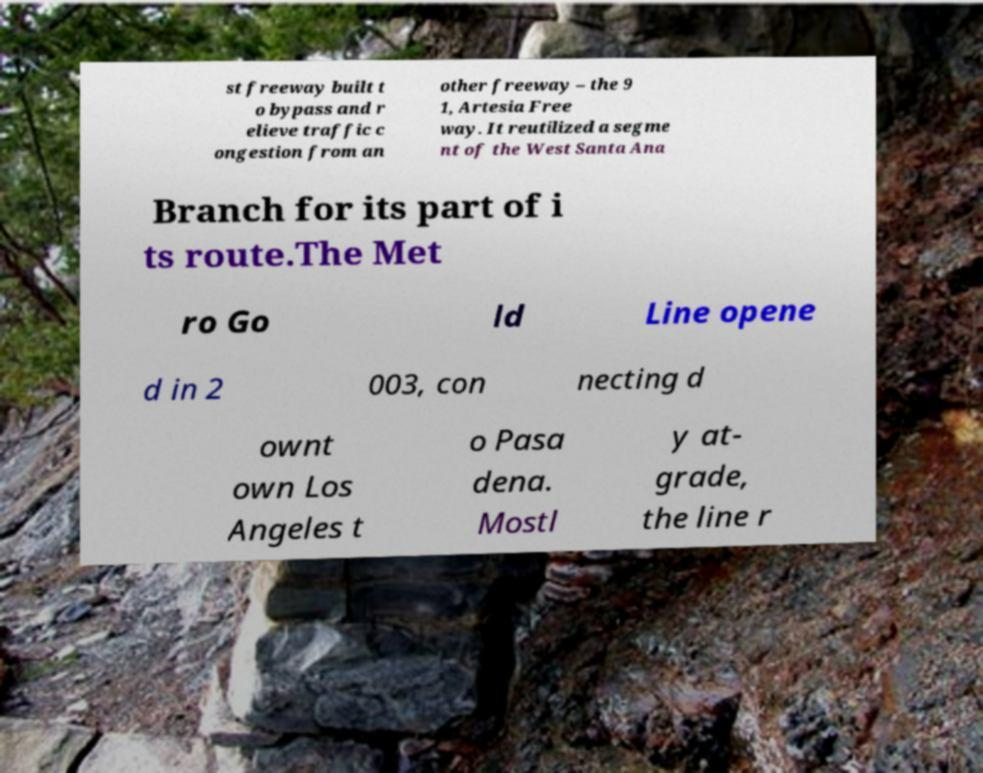For documentation purposes, I need the text within this image transcribed. Could you provide that? st freeway built t o bypass and r elieve traffic c ongestion from an other freeway – the 9 1, Artesia Free way. It reutilized a segme nt of the West Santa Ana Branch for its part of i ts route.The Met ro Go ld Line opene d in 2 003, con necting d ownt own Los Angeles t o Pasa dena. Mostl y at- grade, the line r 